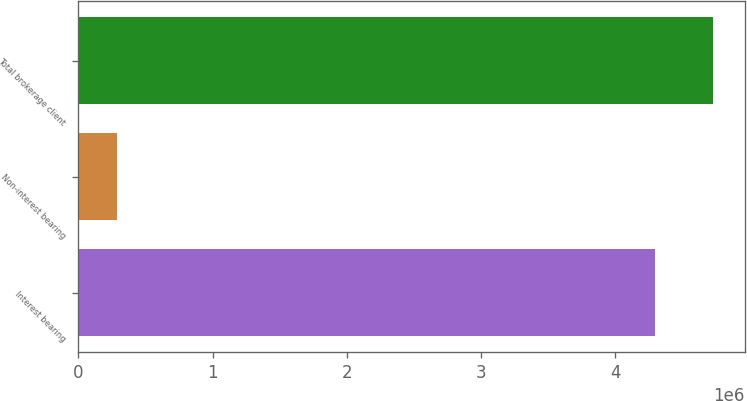Convert chart. <chart><loc_0><loc_0><loc_500><loc_500><bar_chart><fcel>Interest bearing<fcel>Non-interest bearing<fcel>Total brokerage client<nl><fcel>4.29964e+06<fcel>285016<fcel>4.7296e+06<nl></chart> 